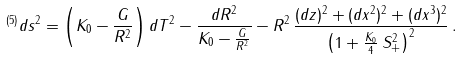Convert formula to latex. <formula><loc_0><loc_0><loc_500><loc_500>^ { ( 5 ) } d s ^ { 2 } = \left ( K _ { 0 } - \frac { G } { R ^ { 2 } } \right ) d T ^ { 2 } - \frac { d R ^ { 2 } } { K _ { 0 } - \frac { G } { R ^ { 2 } } } - R ^ { 2 } \, \frac { ( d z ) ^ { 2 } + ( d x ^ { 2 } ) ^ { 2 } + ( d x ^ { 3 } ) ^ { 2 } } { \left ( 1 + \frac { K _ { 0 } } { 4 } \, S _ { + } ^ { 2 } \right ) ^ { 2 } } \, .</formula> 